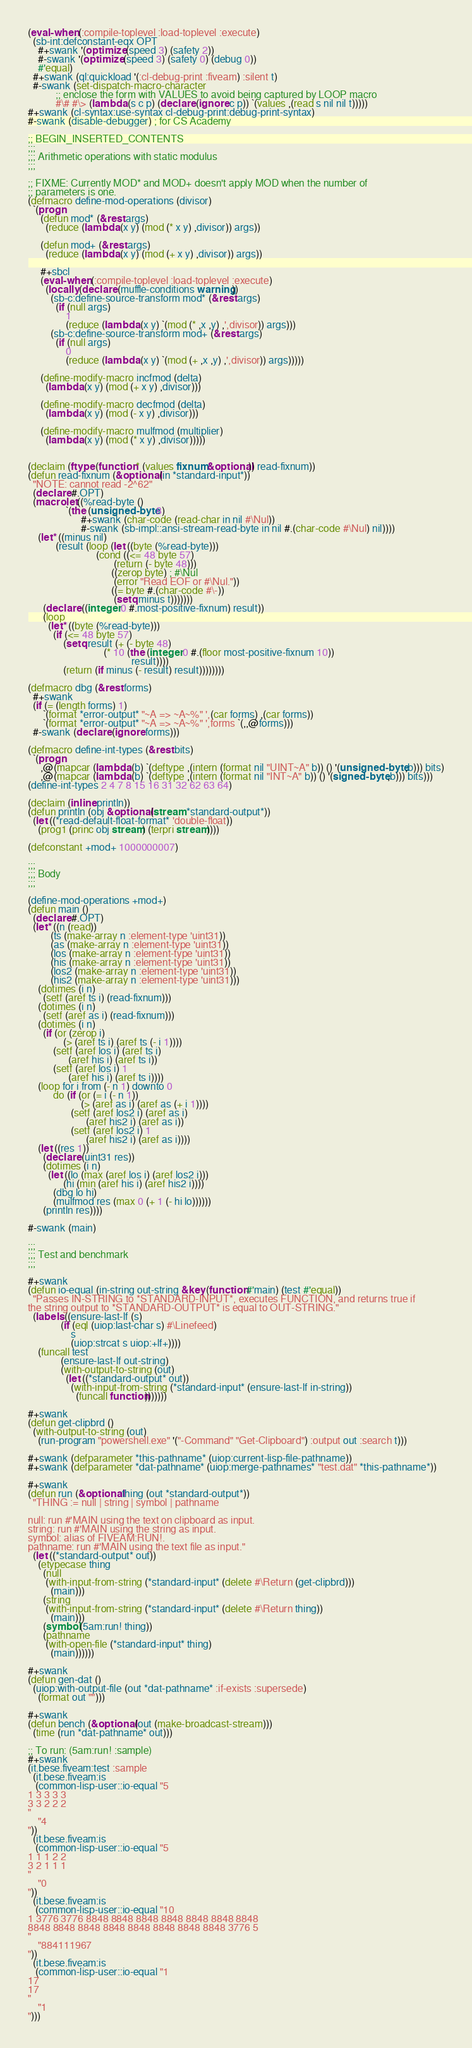<code> <loc_0><loc_0><loc_500><loc_500><_Lisp_>(eval-when (:compile-toplevel :load-toplevel :execute)
  (sb-int:defconstant-eqx OPT
    #+swank '(optimize (speed 3) (safety 2))
    #-swank '(optimize (speed 3) (safety 0) (debug 0))
    #'equal)
  #+swank (ql:quickload '(:cl-debug-print :fiveam) :silent t)
  #-swank (set-dispatch-macro-character
           ;; enclose the form with VALUES to avoid being captured by LOOP macro
           #\# #\> (lambda (s c p) (declare (ignore c p)) `(values ,(read s nil nil t)))))
#+swank (cl-syntax:use-syntax cl-debug-print:debug-print-syntax)
#-swank (disable-debugger) ; for CS Academy

;; BEGIN_INSERTED_CONTENTS
;;;
;;; Arithmetic operations with static modulus
;;;

;; FIXME: Currently MOD* and MOD+ doesn't apply MOD when the number of
;; parameters is one.
(defmacro define-mod-operations (divisor)
  `(progn
     (defun mod* (&rest args)
       (reduce (lambda (x y) (mod (* x y) ,divisor)) args))

     (defun mod+ (&rest args)
       (reduce (lambda (x y) (mod (+ x y) ,divisor)) args))

     #+sbcl
     (eval-when (:compile-toplevel :load-toplevel :execute)
       (locally (declare (muffle-conditions warning))
         (sb-c:define-source-transform mod* (&rest args)
           (if (null args)
               1
               (reduce (lambda (x y) `(mod (* ,x ,y) ,',divisor)) args)))
         (sb-c:define-source-transform mod+ (&rest args)
           (if (null args)
               0
               (reduce (lambda (x y) `(mod (+ ,x ,y) ,',divisor)) args)))))

     (define-modify-macro incfmod (delta)
       (lambda (x y) (mod (+ x y) ,divisor)))

     (define-modify-macro decfmod (delta)
       (lambda (x y) (mod (- x y) ,divisor)))

     (define-modify-macro mulfmod (multiplier)
       (lambda (x y) (mod (* x y) ,divisor)))))


(declaim (ftype (function * (values fixnum &optional)) read-fixnum))
(defun read-fixnum (&optional (in *standard-input*))
  "NOTE: cannot read -2^62"
  (declare #.OPT)
  (macrolet ((%read-byte ()
               `(the (unsigned-byte 8)
                     #+swank (char-code (read-char in nil #\Nul))
                     #-swank (sb-impl::ansi-stream-read-byte in nil #.(char-code #\Nul) nil))))
    (let* ((minus nil)
           (result (loop (let ((byte (%read-byte)))
                           (cond ((<= 48 byte 57)
                                  (return (- byte 48)))
                                 ((zerop byte) ; #\Nul
                                  (error "Read EOF or #\Nul."))
                                 ((= byte #.(char-code #\-))
                                  (setq minus t)))))))
      (declare ((integer 0 #.most-positive-fixnum) result))
      (loop
        (let* ((byte (%read-byte)))
          (if (<= 48 byte 57)
              (setq result (+ (- byte 48)
                              (* 10 (the (integer 0 #.(floor most-positive-fixnum 10))
                                         result))))
              (return (if minus (- result) result))))))))

(defmacro dbg (&rest forms)
  #+swank
  (if (= (length forms) 1)
      `(format *error-output* "~A => ~A~%" ',(car forms) ,(car forms))
      `(format *error-output* "~A => ~A~%" ',forms `(,,@forms)))
  #-swank (declare (ignore forms)))

(defmacro define-int-types (&rest bits)
  `(progn
     ,@(mapcar (lambda (b) `(deftype ,(intern (format nil "UINT~A" b)) () '(unsigned-byte ,b))) bits)
     ,@(mapcar (lambda (b) `(deftype ,(intern (format nil "INT~A" b)) () '(signed-byte ,b))) bits)))
(define-int-types 2 4 7 8 15 16 31 32 62 63 64)

(declaim (inline println))
(defun println (obj &optional (stream *standard-output*))
  (let ((*read-default-float-format* 'double-float))
    (prog1 (princ obj stream) (terpri stream))))

(defconstant +mod+ 1000000007)

;;;
;;; Body
;;;

(define-mod-operations +mod+)
(defun main ()
  (declare #.OPT)
  (let* ((n (read))
         (ts (make-array n :element-type 'uint31))
         (as (make-array n :element-type 'uint31))
         (los (make-array n :element-type 'uint31))
         (his (make-array n :element-type 'uint31))
         (los2 (make-array n :element-type 'uint31))
         (his2 (make-array n :element-type 'uint31)))
    (dotimes (i n)
      (setf (aref ts i) (read-fixnum)))
    (dotimes (i n)
      (setf (aref as i) (read-fixnum)))
    (dotimes (i n)
      (if (or (zerop i)
              (> (aref ts i) (aref ts (- i 1))))
          (setf (aref los i) (aref ts i)
                (aref his i) (aref ts i))
          (setf (aref los i) 1
                (aref his i) (aref ts i))))
    (loop for i from (- n 1) downto 0
          do (if (or (= i (- n 1))
                     (> (aref as i) (aref as (+ i 1))))
                 (setf (aref los2 i) (aref as i)
                       (aref his2 i) (aref as i))
                 (setf (aref los2 i) 1
                       (aref his2 i) (aref as i))))
    (let ((res 1))
      (declare (uint31 res))
      (dotimes (i n)
        (let ((lo (max (aref los i) (aref los2 i)))
              (hi (min (aref his i) (aref his2 i))))
          (dbg lo hi)
          (mulfmod res (max 0 (+ 1 (- hi lo))))))
      (println res))))

#-swank (main)

;;;
;;; Test and benchmark
;;;

#+swank
(defun io-equal (in-string out-string &key (function #'main) (test #'equal))
  "Passes IN-STRING to *STANDARD-INPUT*, executes FUNCTION, and returns true if
the string output to *STANDARD-OUTPUT* is equal to OUT-STRING."
  (labels ((ensure-last-lf (s)
             (if (eql (uiop:last-char s) #\Linefeed)
                 s
                 (uiop:strcat s uiop:+lf+))))
    (funcall test
             (ensure-last-lf out-string)
             (with-output-to-string (out)
               (let ((*standard-output* out))
                 (with-input-from-string (*standard-input* (ensure-last-lf in-string))
                   (funcall function)))))))

#+swank
(defun get-clipbrd ()
  (with-output-to-string (out)
    (run-program "powershell.exe" '("-Command" "Get-Clipboard") :output out :search t)))

#+swank (defparameter *this-pathname* (uiop:current-lisp-file-pathname))
#+swank (defparameter *dat-pathname* (uiop:merge-pathnames* "test.dat" *this-pathname*))

#+swank
(defun run (&optional thing (out *standard-output*))
  "THING := null | string | symbol | pathname

null: run #'MAIN using the text on clipboard as input.
string: run #'MAIN using the string as input.
symbol: alias of FIVEAM:RUN!.
pathname: run #'MAIN using the text file as input."
  (let ((*standard-output* out))
    (etypecase thing
      (null
       (with-input-from-string (*standard-input* (delete #\Return (get-clipbrd)))
         (main)))
      (string
       (with-input-from-string (*standard-input* (delete #\Return thing))
         (main)))
      (symbol (5am:run! thing))
      (pathname
       (with-open-file (*standard-input* thing)
         (main))))))

#+swank
(defun gen-dat ()
  (uiop:with-output-file (out *dat-pathname* :if-exists :supersede)
    (format out "")))

#+swank
(defun bench (&optional (out (make-broadcast-stream)))
  (time (run *dat-pathname* out)))

;; To run: (5am:run! :sample)
#+swank
(it.bese.fiveam:test :sample
  (it.bese.fiveam:is
   (common-lisp-user::io-equal "5
1 3 3 3 3
3 3 2 2 2
"
    "4
"))
  (it.bese.fiveam:is
   (common-lisp-user::io-equal "5
1 1 1 2 2
3 2 1 1 1
"
    "0
"))
  (it.bese.fiveam:is
   (common-lisp-user::io-equal "10
1 3776 3776 8848 8848 8848 8848 8848 8848 8848
8848 8848 8848 8848 8848 8848 8848 8848 3776 5
"
    "884111967
"))
  (it.bese.fiveam:is
   (common-lisp-user::io-equal "1
17
17
"
    "1
")))
</code> 